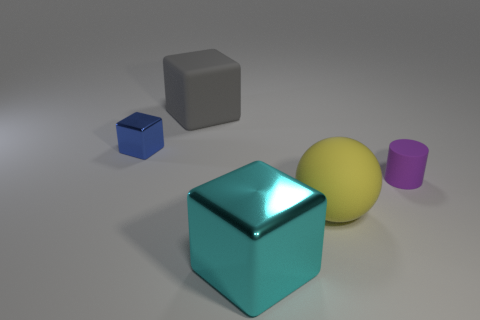Is there any other thing that has the same shape as the large cyan metal thing?
Your answer should be compact. Yes. Does the large gray thing have the same shape as the small purple matte object?
Offer a terse response. No. Are there any other things that are made of the same material as the big cyan thing?
Ensure brevity in your answer.  Yes. How big is the yellow sphere?
Ensure brevity in your answer.  Large. What color is the object that is in front of the large matte block and to the left of the cyan metal object?
Make the answer very short. Blue. Is the number of large purple objects greater than the number of big cyan shiny things?
Offer a very short reply. No. What number of objects are spheres or small things on the right side of the tiny blue cube?
Your response must be concise. 2. Does the purple matte thing have the same size as the matte ball?
Your response must be concise. No. There is a small purple matte thing; are there any rubber cubes in front of it?
Ensure brevity in your answer.  No. There is a rubber thing that is in front of the rubber block and behind the yellow ball; what is its size?
Offer a terse response. Small. 